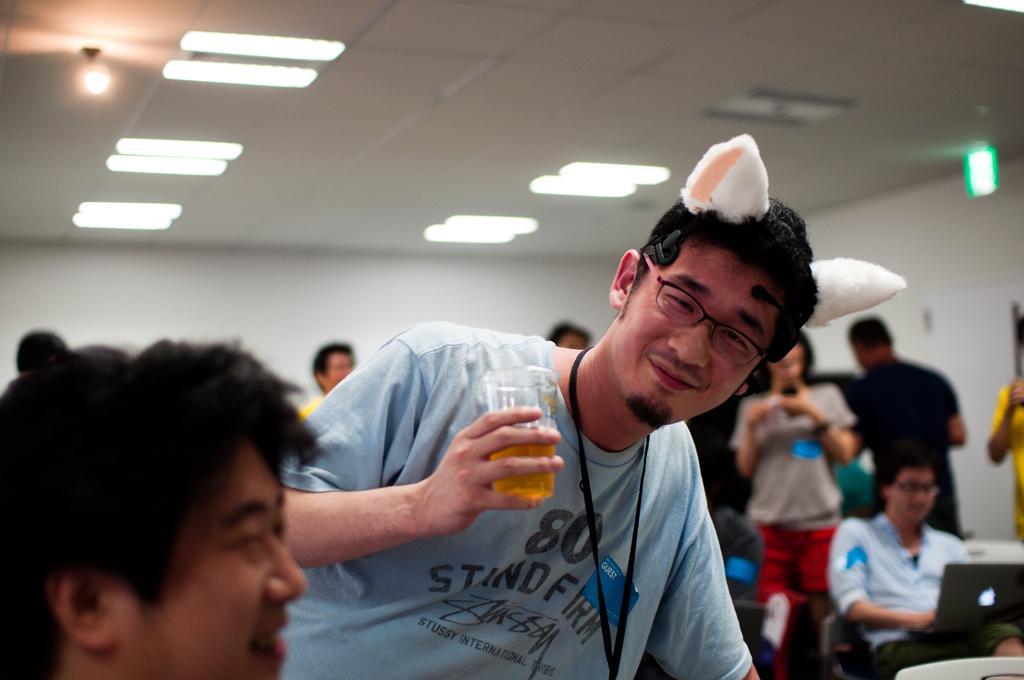How would you summarize this image in a sentence or two? In the center of the image we can see a man holding a glass and there are people sitting. We can see a laptop. In the background there is a wall. At the top there are lights. 